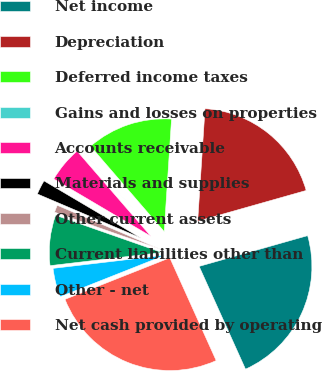<chart> <loc_0><loc_0><loc_500><loc_500><pie_chart><fcel>Net income<fcel>Depreciation<fcel>Deferred income taxes<fcel>Gains and losses on properties<fcel>Accounts receivable<fcel>Materials and supplies<fcel>Other current assets<fcel>Current liabilities other than<fcel>Other - net<fcel>Net cash provided by operating<nl><fcel>22.65%<fcel>19.57%<fcel>12.37%<fcel>0.02%<fcel>5.16%<fcel>2.08%<fcel>1.05%<fcel>7.22%<fcel>4.14%<fcel>25.74%<nl></chart> 